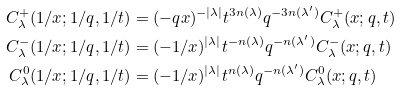<formula> <loc_0><loc_0><loc_500><loc_500>C ^ { + } _ { \lambda } ( 1 / x ; 1 / q , 1 / t ) & = ( - q x ) ^ { - | \lambda | } t ^ { 3 n ( \lambda ) } q ^ { - 3 n ( \lambda ^ { \prime } ) } C ^ { + } _ { \lambda } ( x ; q , t ) \\ C ^ { - } _ { \lambda } ( 1 / x ; 1 / q , 1 / t ) & = ( - 1 / x ) ^ { | \lambda | } t ^ { - n ( \lambda ) } q ^ { - n ( \lambda ^ { \prime } ) } C ^ { - } _ { \lambda } ( x ; q , t ) \\ C ^ { 0 } _ { \lambda } ( 1 / x ; 1 / q , 1 / t ) & = ( - 1 / x ) ^ { | \lambda | } t ^ { n ( \lambda ) } q ^ { - n ( \lambda ^ { \prime } ) } C ^ { 0 } _ { \lambda } ( x ; q , t )</formula> 